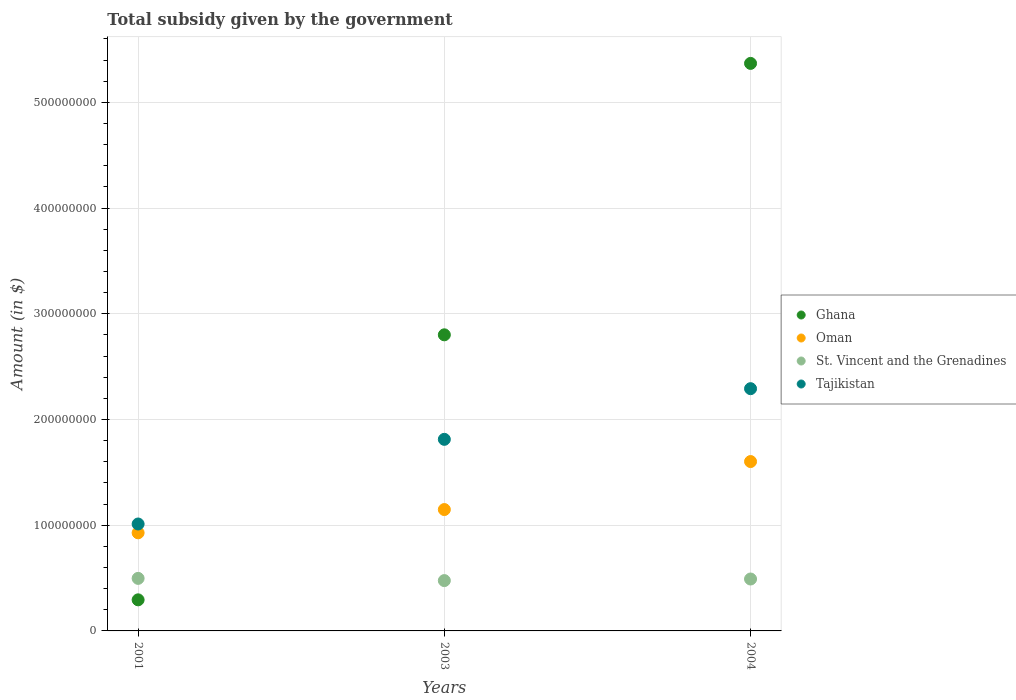How many different coloured dotlines are there?
Keep it short and to the point. 4. What is the total revenue collected by the government in Ghana in 2004?
Provide a short and direct response. 5.37e+08. Across all years, what is the maximum total revenue collected by the government in Oman?
Offer a very short reply. 1.60e+08. Across all years, what is the minimum total revenue collected by the government in Oman?
Your response must be concise. 9.28e+07. What is the total total revenue collected by the government in Oman in the graph?
Your response must be concise. 3.68e+08. What is the difference between the total revenue collected by the government in Oman in 2003 and that in 2004?
Your response must be concise. -4.54e+07. What is the difference between the total revenue collected by the government in St. Vincent and the Grenadines in 2004 and the total revenue collected by the government in Oman in 2003?
Your answer should be very brief. -6.57e+07. What is the average total revenue collected by the government in Oman per year?
Ensure brevity in your answer.  1.23e+08. In the year 2001, what is the difference between the total revenue collected by the government in Ghana and total revenue collected by the government in Tajikistan?
Keep it short and to the point. -7.17e+07. In how many years, is the total revenue collected by the government in Oman greater than 160000000 $?
Make the answer very short. 1. What is the ratio of the total revenue collected by the government in St. Vincent and the Grenadines in 2001 to that in 2004?
Ensure brevity in your answer.  1.01. What is the difference between the highest and the second highest total revenue collected by the government in Ghana?
Keep it short and to the point. 2.57e+08. What is the difference between the highest and the lowest total revenue collected by the government in St. Vincent and the Grenadines?
Provide a short and direct response. 2.10e+06. In how many years, is the total revenue collected by the government in Oman greater than the average total revenue collected by the government in Oman taken over all years?
Your response must be concise. 1. Is the sum of the total revenue collected by the government in Ghana in 2003 and 2004 greater than the maximum total revenue collected by the government in Oman across all years?
Your answer should be compact. Yes. Is the total revenue collected by the government in Oman strictly greater than the total revenue collected by the government in Ghana over the years?
Provide a short and direct response. No. Is the total revenue collected by the government in Tajikistan strictly less than the total revenue collected by the government in Ghana over the years?
Provide a short and direct response. No. What is the difference between two consecutive major ticks on the Y-axis?
Provide a short and direct response. 1.00e+08. Are the values on the major ticks of Y-axis written in scientific E-notation?
Make the answer very short. No. Does the graph contain any zero values?
Provide a succinct answer. No. Does the graph contain grids?
Offer a very short reply. Yes. What is the title of the graph?
Give a very brief answer. Total subsidy given by the government. Does "Serbia" appear as one of the legend labels in the graph?
Your answer should be very brief. No. What is the label or title of the Y-axis?
Offer a very short reply. Amount (in $). What is the Amount (in $) in Ghana in 2001?
Offer a terse response. 2.94e+07. What is the Amount (in $) of Oman in 2001?
Provide a short and direct response. 9.28e+07. What is the Amount (in $) in St. Vincent and the Grenadines in 2001?
Provide a short and direct response. 4.97e+07. What is the Amount (in $) in Tajikistan in 2001?
Ensure brevity in your answer.  1.01e+08. What is the Amount (in $) in Ghana in 2003?
Make the answer very short. 2.80e+08. What is the Amount (in $) in Oman in 2003?
Your response must be concise. 1.15e+08. What is the Amount (in $) in St. Vincent and the Grenadines in 2003?
Offer a very short reply. 4.76e+07. What is the Amount (in $) of Tajikistan in 2003?
Provide a short and direct response. 1.81e+08. What is the Amount (in $) in Ghana in 2004?
Offer a very short reply. 5.37e+08. What is the Amount (in $) in Oman in 2004?
Your answer should be compact. 1.60e+08. What is the Amount (in $) in St. Vincent and the Grenadines in 2004?
Provide a short and direct response. 4.91e+07. What is the Amount (in $) in Tajikistan in 2004?
Provide a short and direct response. 2.29e+08. Across all years, what is the maximum Amount (in $) of Ghana?
Offer a very short reply. 5.37e+08. Across all years, what is the maximum Amount (in $) in Oman?
Give a very brief answer. 1.60e+08. Across all years, what is the maximum Amount (in $) in St. Vincent and the Grenadines?
Provide a short and direct response. 4.97e+07. Across all years, what is the maximum Amount (in $) of Tajikistan?
Offer a terse response. 2.29e+08. Across all years, what is the minimum Amount (in $) in Ghana?
Offer a terse response. 2.94e+07. Across all years, what is the minimum Amount (in $) in Oman?
Provide a short and direct response. 9.28e+07. Across all years, what is the minimum Amount (in $) of St. Vincent and the Grenadines?
Provide a short and direct response. 4.76e+07. Across all years, what is the minimum Amount (in $) in Tajikistan?
Give a very brief answer. 1.01e+08. What is the total Amount (in $) of Ghana in the graph?
Your answer should be compact. 8.46e+08. What is the total Amount (in $) of Oman in the graph?
Give a very brief answer. 3.68e+08. What is the total Amount (in $) of St. Vincent and the Grenadines in the graph?
Offer a terse response. 1.46e+08. What is the total Amount (in $) of Tajikistan in the graph?
Provide a succinct answer. 5.11e+08. What is the difference between the Amount (in $) of Ghana in 2001 and that in 2003?
Provide a succinct answer. -2.51e+08. What is the difference between the Amount (in $) in Oman in 2001 and that in 2003?
Your response must be concise. -2.20e+07. What is the difference between the Amount (in $) of St. Vincent and the Grenadines in 2001 and that in 2003?
Keep it short and to the point. 2.10e+06. What is the difference between the Amount (in $) in Tajikistan in 2001 and that in 2003?
Keep it short and to the point. -8.01e+07. What is the difference between the Amount (in $) in Ghana in 2001 and that in 2004?
Keep it short and to the point. -5.07e+08. What is the difference between the Amount (in $) of Oman in 2001 and that in 2004?
Offer a very short reply. -6.74e+07. What is the difference between the Amount (in $) of St. Vincent and the Grenadines in 2001 and that in 2004?
Give a very brief answer. 6.00e+05. What is the difference between the Amount (in $) of Tajikistan in 2001 and that in 2004?
Provide a short and direct response. -1.28e+08. What is the difference between the Amount (in $) in Ghana in 2003 and that in 2004?
Give a very brief answer. -2.57e+08. What is the difference between the Amount (in $) in Oman in 2003 and that in 2004?
Ensure brevity in your answer.  -4.54e+07. What is the difference between the Amount (in $) of St. Vincent and the Grenadines in 2003 and that in 2004?
Provide a succinct answer. -1.50e+06. What is the difference between the Amount (in $) in Tajikistan in 2003 and that in 2004?
Offer a very short reply. -4.79e+07. What is the difference between the Amount (in $) of Ghana in 2001 and the Amount (in $) of Oman in 2003?
Give a very brief answer. -8.54e+07. What is the difference between the Amount (in $) of Ghana in 2001 and the Amount (in $) of St. Vincent and the Grenadines in 2003?
Make the answer very short. -1.82e+07. What is the difference between the Amount (in $) of Ghana in 2001 and the Amount (in $) of Tajikistan in 2003?
Your answer should be very brief. -1.52e+08. What is the difference between the Amount (in $) in Oman in 2001 and the Amount (in $) in St. Vincent and the Grenadines in 2003?
Make the answer very short. 4.52e+07. What is the difference between the Amount (in $) of Oman in 2001 and the Amount (in $) of Tajikistan in 2003?
Keep it short and to the point. -8.84e+07. What is the difference between the Amount (in $) in St. Vincent and the Grenadines in 2001 and the Amount (in $) in Tajikistan in 2003?
Provide a short and direct response. -1.32e+08. What is the difference between the Amount (in $) in Ghana in 2001 and the Amount (in $) in Oman in 2004?
Provide a short and direct response. -1.31e+08. What is the difference between the Amount (in $) of Ghana in 2001 and the Amount (in $) of St. Vincent and the Grenadines in 2004?
Offer a terse response. -1.97e+07. What is the difference between the Amount (in $) in Ghana in 2001 and the Amount (in $) in Tajikistan in 2004?
Provide a succinct answer. -2.00e+08. What is the difference between the Amount (in $) in Oman in 2001 and the Amount (in $) in St. Vincent and the Grenadines in 2004?
Ensure brevity in your answer.  4.37e+07. What is the difference between the Amount (in $) of Oman in 2001 and the Amount (in $) of Tajikistan in 2004?
Your answer should be very brief. -1.36e+08. What is the difference between the Amount (in $) of St. Vincent and the Grenadines in 2001 and the Amount (in $) of Tajikistan in 2004?
Offer a very short reply. -1.79e+08. What is the difference between the Amount (in $) in Ghana in 2003 and the Amount (in $) in Oman in 2004?
Keep it short and to the point. 1.20e+08. What is the difference between the Amount (in $) of Ghana in 2003 and the Amount (in $) of St. Vincent and the Grenadines in 2004?
Give a very brief answer. 2.31e+08. What is the difference between the Amount (in $) of Ghana in 2003 and the Amount (in $) of Tajikistan in 2004?
Provide a short and direct response. 5.09e+07. What is the difference between the Amount (in $) of Oman in 2003 and the Amount (in $) of St. Vincent and the Grenadines in 2004?
Keep it short and to the point. 6.57e+07. What is the difference between the Amount (in $) of Oman in 2003 and the Amount (in $) of Tajikistan in 2004?
Your answer should be compact. -1.14e+08. What is the difference between the Amount (in $) of St. Vincent and the Grenadines in 2003 and the Amount (in $) of Tajikistan in 2004?
Give a very brief answer. -1.82e+08. What is the average Amount (in $) in Ghana per year?
Ensure brevity in your answer.  2.82e+08. What is the average Amount (in $) of Oman per year?
Give a very brief answer. 1.23e+08. What is the average Amount (in $) in St. Vincent and the Grenadines per year?
Keep it short and to the point. 4.88e+07. What is the average Amount (in $) of Tajikistan per year?
Offer a very short reply. 1.70e+08. In the year 2001, what is the difference between the Amount (in $) of Ghana and Amount (in $) of Oman?
Keep it short and to the point. -6.34e+07. In the year 2001, what is the difference between the Amount (in $) of Ghana and Amount (in $) of St. Vincent and the Grenadines?
Keep it short and to the point. -2.03e+07. In the year 2001, what is the difference between the Amount (in $) in Ghana and Amount (in $) in Tajikistan?
Offer a very short reply. -7.17e+07. In the year 2001, what is the difference between the Amount (in $) of Oman and Amount (in $) of St. Vincent and the Grenadines?
Provide a succinct answer. 4.31e+07. In the year 2001, what is the difference between the Amount (in $) in Oman and Amount (in $) in Tajikistan?
Give a very brief answer. -8.34e+06. In the year 2001, what is the difference between the Amount (in $) of St. Vincent and the Grenadines and Amount (in $) of Tajikistan?
Your answer should be compact. -5.14e+07. In the year 2003, what is the difference between the Amount (in $) of Ghana and Amount (in $) of Oman?
Offer a very short reply. 1.65e+08. In the year 2003, what is the difference between the Amount (in $) of Ghana and Amount (in $) of St. Vincent and the Grenadines?
Give a very brief answer. 2.32e+08. In the year 2003, what is the difference between the Amount (in $) in Ghana and Amount (in $) in Tajikistan?
Keep it short and to the point. 9.89e+07. In the year 2003, what is the difference between the Amount (in $) of Oman and Amount (in $) of St. Vincent and the Grenadines?
Offer a terse response. 6.72e+07. In the year 2003, what is the difference between the Amount (in $) in Oman and Amount (in $) in Tajikistan?
Make the answer very short. -6.64e+07. In the year 2003, what is the difference between the Amount (in $) of St. Vincent and the Grenadines and Amount (in $) of Tajikistan?
Your response must be concise. -1.34e+08. In the year 2004, what is the difference between the Amount (in $) in Ghana and Amount (in $) in Oman?
Give a very brief answer. 3.77e+08. In the year 2004, what is the difference between the Amount (in $) in Ghana and Amount (in $) in St. Vincent and the Grenadines?
Provide a succinct answer. 4.88e+08. In the year 2004, what is the difference between the Amount (in $) of Ghana and Amount (in $) of Tajikistan?
Keep it short and to the point. 3.08e+08. In the year 2004, what is the difference between the Amount (in $) of Oman and Amount (in $) of St. Vincent and the Grenadines?
Offer a very short reply. 1.11e+08. In the year 2004, what is the difference between the Amount (in $) in Oman and Amount (in $) in Tajikistan?
Make the answer very short. -6.89e+07. In the year 2004, what is the difference between the Amount (in $) of St. Vincent and the Grenadines and Amount (in $) of Tajikistan?
Offer a terse response. -1.80e+08. What is the ratio of the Amount (in $) in Ghana in 2001 to that in 2003?
Make the answer very short. 0.1. What is the ratio of the Amount (in $) in Oman in 2001 to that in 2003?
Make the answer very short. 0.81. What is the ratio of the Amount (in $) in St. Vincent and the Grenadines in 2001 to that in 2003?
Your response must be concise. 1.04. What is the ratio of the Amount (in $) in Tajikistan in 2001 to that in 2003?
Provide a succinct answer. 0.56. What is the ratio of the Amount (in $) in Ghana in 2001 to that in 2004?
Your response must be concise. 0.05. What is the ratio of the Amount (in $) in Oman in 2001 to that in 2004?
Keep it short and to the point. 0.58. What is the ratio of the Amount (in $) of St. Vincent and the Grenadines in 2001 to that in 2004?
Your response must be concise. 1.01. What is the ratio of the Amount (in $) in Tajikistan in 2001 to that in 2004?
Offer a terse response. 0.44. What is the ratio of the Amount (in $) in Ghana in 2003 to that in 2004?
Ensure brevity in your answer.  0.52. What is the ratio of the Amount (in $) in Oman in 2003 to that in 2004?
Offer a very short reply. 0.72. What is the ratio of the Amount (in $) of St. Vincent and the Grenadines in 2003 to that in 2004?
Ensure brevity in your answer.  0.97. What is the ratio of the Amount (in $) of Tajikistan in 2003 to that in 2004?
Your answer should be compact. 0.79. What is the difference between the highest and the second highest Amount (in $) in Ghana?
Your answer should be compact. 2.57e+08. What is the difference between the highest and the second highest Amount (in $) in Oman?
Your answer should be very brief. 4.54e+07. What is the difference between the highest and the second highest Amount (in $) in Tajikistan?
Offer a terse response. 4.79e+07. What is the difference between the highest and the lowest Amount (in $) of Ghana?
Your answer should be compact. 5.07e+08. What is the difference between the highest and the lowest Amount (in $) in Oman?
Offer a very short reply. 6.74e+07. What is the difference between the highest and the lowest Amount (in $) of St. Vincent and the Grenadines?
Keep it short and to the point. 2.10e+06. What is the difference between the highest and the lowest Amount (in $) of Tajikistan?
Your response must be concise. 1.28e+08. 